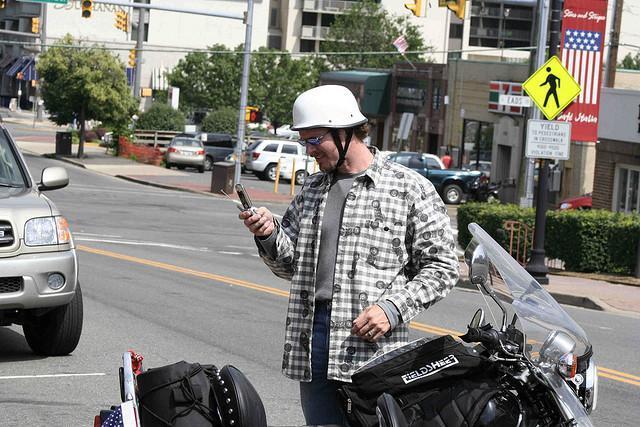How many backpacks are visible?
Give a very brief answer. 2. How many cars are in the photo?
Give a very brief answer. 1. How many teddy bears are wearing a hair bow?
Give a very brief answer. 0. 